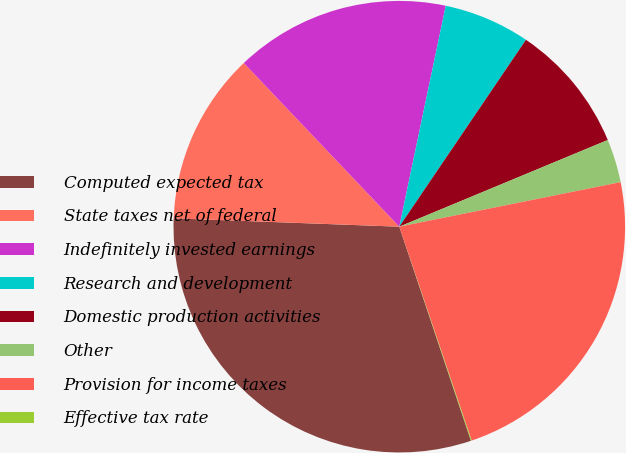Convert chart to OTSL. <chart><loc_0><loc_0><loc_500><loc_500><pie_chart><fcel>Computed expected tax<fcel>State taxes net of federal<fcel>Indefinitely invested earnings<fcel>Research and development<fcel>Domestic production activities<fcel>Other<fcel>Provision for income taxes<fcel>Effective tax rate<nl><fcel>30.73%<fcel>12.32%<fcel>15.39%<fcel>6.18%<fcel>9.25%<fcel>3.11%<fcel>22.97%<fcel>0.05%<nl></chart> 